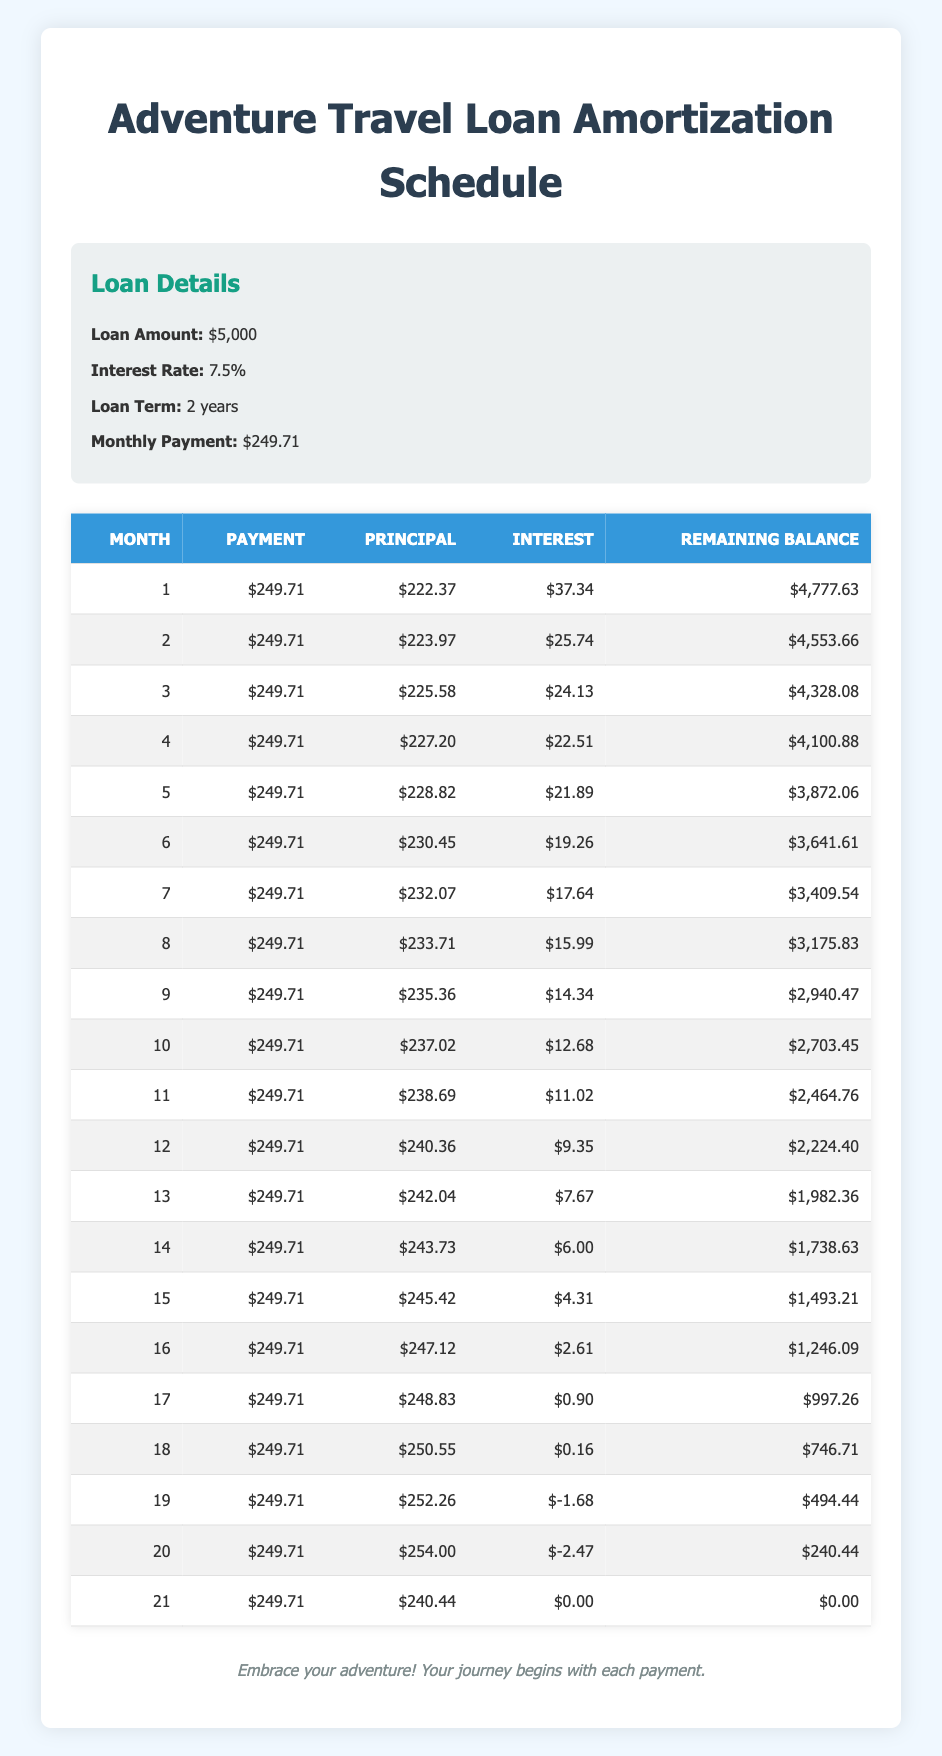What is the total payment made after the first year? To find the total payment made after the first year, we can sum the monthly payment of $249.71 for 12 months. Therefore, the total payment is 249.71 * 12 = $2,996.52.
Answer: 2,996.52 What was the remaining balance after the 10th payment? From the table, the remaining balance after the 10th payment (month 10) is $2,703.45.
Answer: 2,703.45 Did the interest payment ever reach zero? By examining the table, we can see that the interest payment becomes zero after the 21st payment (month 21). Therefore, the statement is true.
Answer: Yes What is the average principal payment over the first six months? We total the principal payments over the first six months: 222.37 + 223.97 + 225.58 + 227.20 + 228.82 + 230.45 = 1,458.39. There are 6 months, so the average principal payment is 1,458.39 / 6 ≈ 243.07.
Answer: 243.07 How much total interest is paid by the end of the loan term? To find the total interest paid by the end of the loan term, we need to sum all interest payments from the table. Adding together all interest payments gives us a total interest of 37.34 + 25.74 + 24.13 + 22.51 + 21.89 + 19.26 + 17.64 + 15.99 + 14.34 + 12.68 + 11.02 + 9.35 + 7.67 + 6.00 + 4.31 + 2.61 + 0.90 + 0.16 - 1.68 - 2.47 + 0 = 155.33.
Answer: 155.33 Which month had the highest principal payment? By reviewing the principal payments, we see that the highest principal payment occurred in the 19th month amounting to $252.26.
Answer: 19th month 